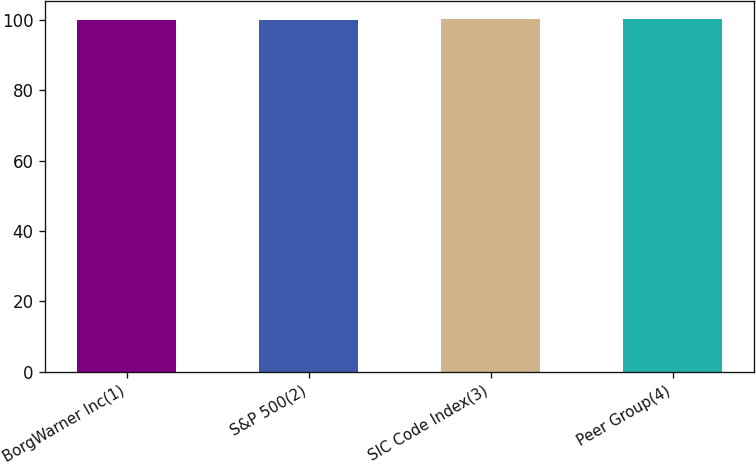Convert chart to OTSL. <chart><loc_0><loc_0><loc_500><loc_500><bar_chart><fcel>BorgWarner Inc(1)<fcel>S&P 500(2)<fcel>SIC Code Index(3)<fcel>Peer Group(4)<nl><fcel>100<fcel>100.1<fcel>100.2<fcel>100.3<nl></chart> 